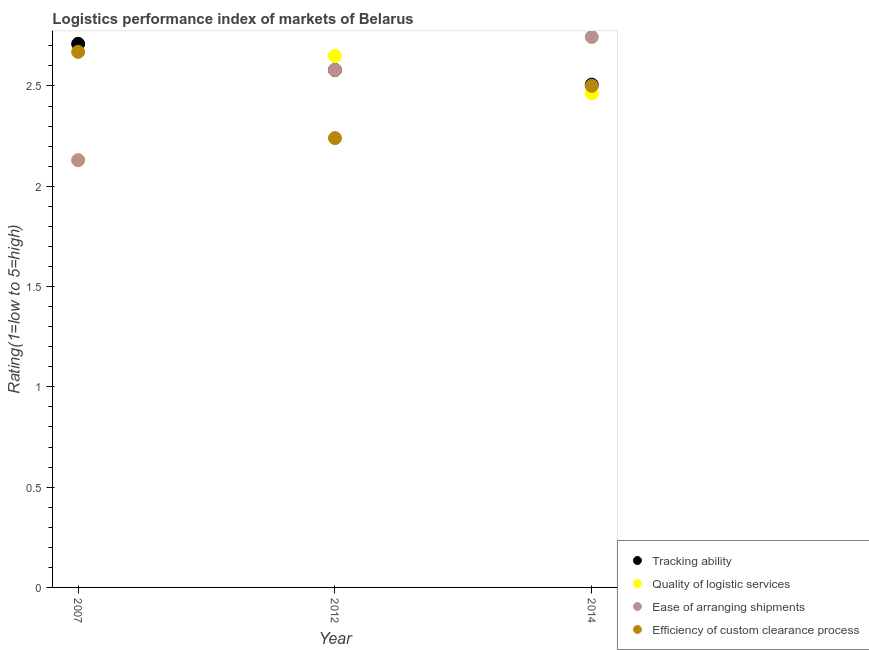Is the number of dotlines equal to the number of legend labels?
Your response must be concise. Yes. What is the lpi rating of tracking ability in 2007?
Keep it short and to the point. 2.71. Across all years, what is the maximum lpi rating of efficiency of custom clearance process?
Ensure brevity in your answer.  2.67. Across all years, what is the minimum lpi rating of tracking ability?
Ensure brevity in your answer.  2.51. What is the total lpi rating of ease of arranging shipments in the graph?
Keep it short and to the point. 7.45. What is the difference between the lpi rating of efficiency of custom clearance process in 2007 and that in 2012?
Keep it short and to the point. 0.43. What is the difference between the lpi rating of quality of logistic services in 2007 and the lpi rating of efficiency of custom clearance process in 2014?
Offer a very short reply. -0.37. What is the average lpi rating of efficiency of custom clearance process per year?
Provide a short and direct response. 2.47. In the year 2012, what is the difference between the lpi rating of tracking ability and lpi rating of quality of logistic services?
Give a very brief answer. -0.07. What is the ratio of the lpi rating of ease of arranging shipments in 2007 to that in 2012?
Your answer should be very brief. 0.83. Is the lpi rating of quality of logistic services in 2007 less than that in 2012?
Offer a very short reply. Yes. Is the difference between the lpi rating of tracking ability in 2012 and 2014 greater than the difference between the lpi rating of quality of logistic services in 2012 and 2014?
Provide a succinct answer. No. What is the difference between the highest and the second highest lpi rating of quality of logistic services?
Keep it short and to the point. 0.19. What is the difference between the highest and the lowest lpi rating of efficiency of custom clearance process?
Keep it short and to the point. 0.43. Does the lpi rating of ease of arranging shipments monotonically increase over the years?
Offer a terse response. Yes. How many dotlines are there?
Keep it short and to the point. 4. How many years are there in the graph?
Provide a succinct answer. 3. Does the graph contain any zero values?
Your response must be concise. No. How many legend labels are there?
Offer a very short reply. 4. What is the title of the graph?
Provide a short and direct response. Logistics performance index of markets of Belarus. Does "Permission" appear as one of the legend labels in the graph?
Ensure brevity in your answer.  No. What is the label or title of the Y-axis?
Provide a succinct answer. Rating(1=low to 5=high). What is the Rating(1=low to 5=high) in Tracking ability in 2007?
Provide a short and direct response. 2.71. What is the Rating(1=low to 5=high) in Quality of logistic services in 2007?
Keep it short and to the point. 2.13. What is the Rating(1=low to 5=high) in Ease of arranging shipments in 2007?
Make the answer very short. 2.13. What is the Rating(1=low to 5=high) in Efficiency of custom clearance process in 2007?
Keep it short and to the point. 2.67. What is the Rating(1=low to 5=high) in Tracking ability in 2012?
Keep it short and to the point. 2.58. What is the Rating(1=low to 5=high) in Quality of logistic services in 2012?
Provide a succinct answer. 2.65. What is the Rating(1=low to 5=high) in Ease of arranging shipments in 2012?
Your response must be concise. 2.58. What is the Rating(1=low to 5=high) in Efficiency of custom clearance process in 2012?
Keep it short and to the point. 2.24. What is the Rating(1=low to 5=high) in Tracking ability in 2014?
Offer a very short reply. 2.51. What is the Rating(1=low to 5=high) of Quality of logistic services in 2014?
Provide a short and direct response. 2.46. What is the Rating(1=low to 5=high) in Ease of arranging shipments in 2014?
Your answer should be compact. 2.74. What is the Rating(1=low to 5=high) of Efficiency of custom clearance process in 2014?
Offer a very short reply. 2.5. Across all years, what is the maximum Rating(1=low to 5=high) in Tracking ability?
Offer a terse response. 2.71. Across all years, what is the maximum Rating(1=low to 5=high) in Quality of logistic services?
Offer a terse response. 2.65. Across all years, what is the maximum Rating(1=low to 5=high) in Ease of arranging shipments?
Ensure brevity in your answer.  2.74. Across all years, what is the maximum Rating(1=low to 5=high) in Efficiency of custom clearance process?
Offer a terse response. 2.67. Across all years, what is the minimum Rating(1=low to 5=high) in Tracking ability?
Your answer should be very brief. 2.51. Across all years, what is the minimum Rating(1=low to 5=high) in Quality of logistic services?
Provide a short and direct response. 2.13. Across all years, what is the minimum Rating(1=low to 5=high) in Ease of arranging shipments?
Keep it short and to the point. 2.13. Across all years, what is the minimum Rating(1=low to 5=high) of Efficiency of custom clearance process?
Your answer should be compact. 2.24. What is the total Rating(1=low to 5=high) of Tracking ability in the graph?
Provide a succinct answer. 7.8. What is the total Rating(1=low to 5=high) in Quality of logistic services in the graph?
Provide a short and direct response. 7.24. What is the total Rating(1=low to 5=high) in Ease of arranging shipments in the graph?
Give a very brief answer. 7.45. What is the total Rating(1=low to 5=high) of Efficiency of custom clearance process in the graph?
Offer a terse response. 7.41. What is the difference between the Rating(1=low to 5=high) of Tracking ability in 2007 and that in 2012?
Your answer should be very brief. 0.13. What is the difference between the Rating(1=low to 5=high) in Quality of logistic services in 2007 and that in 2012?
Ensure brevity in your answer.  -0.52. What is the difference between the Rating(1=low to 5=high) of Ease of arranging shipments in 2007 and that in 2012?
Your answer should be very brief. -0.45. What is the difference between the Rating(1=low to 5=high) in Efficiency of custom clearance process in 2007 and that in 2012?
Ensure brevity in your answer.  0.43. What is the difference between the Rating(1=low to 5=high) in Tracking ability in 2007 and that in 2014?
Your answer should be very brief. 0.2. What is the difference between the Rating(1=low to 5=high) of Quality of logistic services in 2007 and that in 2014?
Your answer should be compact. -0.33. What is the difference between the Rating(1=low to 5=high) of Ease of arranging shipments in 2007 and that in 2014?
Provide a succinct answer. -0.61. What is the difference between the Rating(1=low to 5=high) in Efficiency of custom clearance process in 2007 and that in 2014?
Provide a succinct answer. 0.17. What is the difference between the Rating(1=low to 5=high) of Tracking ability in 2012 and that in 2014?
Your response must be concise. 0.07. What is the difference between the Rating(1=low to 5=high) of Quality of logistic services in 2012 and that in 2014?
Offer a terse response. 0.19. What is the difference between the Rating(1=low to 5=high) of Ease of arranging shipments in 2012 and that in 2014?
Your answer should be compact. -0.16. What is the difference between the Rating(1=low to 5=high) in Efficiency of custom clearance process in 2012 and that in 2014?
Your answer should be compact. -0.26. What is the difference between the Rating(1=low to 5=high) of Tracking ability in 2007 and the Rating(1=low to 5=high) of Ease of arranging shipments in 2012?
Your answer should be compact. 0.13. What is the difference between the Rating(1=low to 5=high) of Tracking ability in 2007 and the Rating(1=low to 5=high) of Efficiency of custom clearance process in 2012?
Your answer should be compact. 0.47. What is the difference between the Rating(1=low to 5=high) of Quality of logistic services in 2007 and the Rating(1=low to 5=high) of Ease of arranging shipments in 2012?
Make the answer very short. -0.45. What is the difference between the Rating(1=low to 5=high) of Quality of logistic services in 2007 and the Rating(1=low to 5=high) of Efficiency of custom clearance process in 2012?
Keep it short and to the point. -0.11. What is the difference between the Rating(1=low to 5=high) in Ease of arranging shipments in 2007 and the Rating(1=low to 5=high) in Efficiency of custom clearance process in 2012?
Your answer should be compact. -0.11. What is the difference between the Rating(1=low to 5=high) in Tracking ability in 2007 and the Rating(1=low to 5=high) in Quality of logistic services in 2014?
Offer a terse response. 0.25. What is the difference between the Rating(1=low to 5=high) of Tracking ability in 2007 and the Rating(1=low to 5=high) of Ease of arranging shipments in 2014?
Make the answer very short. -0.03. What is the difference between the Rating(1=low to 5=high) in Tracking ability in 2007 and the Rating(1=low to 5=high) in Efficiency of custom clearance process in 2014?
Your answer should be compact. 0.21. What is the difference between the Rating(1=low to 5=high) in Quality of logistic services in 2007 and the Rating(1=low to 5=high) in Ease of arranging shipments in 2014?
Provide a short and direct response. -0.61. What is the difference between the Rating(1=low to 5=high) of Quality of logistic services in 2007 and the Rating(1=low to 5=high) of Efficiency of custom clearance process in 2014?
Give a very brief answer. -0.37. What is the difference between the Rating(1=low to 5=high) of Ease of arranging shipments in 2007 and the Rating(1=low to 5=high) of Efficiency of custom clearance process in 2014?
Make the answer very short. -0.37. What is the difference between the Rating(1=low to 5=high) of Tracking ability in 2012 and the Rating(1=low to 5=high) of Quality of logistic services in 2014?
Make the answer very short. 0.12. What is the difference between the Rating(1=low to 5=high) of Tracking ability in 2012 and the Rating(1=low to 5=high) of Ease of arranging shipments in 2014?
Ensure brevity in your answer.  -0.16. What is the difference between the Rating(1=low to 5=high) in Tracking ability in 2012 and the Rating(1=low to 5=high) in Efficiency of custom clearance process in 2014?
Provide a succinct answer. 0.08. What is the difference between the Rating(1=low to 5=high) in Quality of logistic services in 2012 and the Rating(1=low to 5=high) in Ease of arranging shipments in 2014?
Ensure brevity in your answer.  -0.09. What is the difference between the Rating(1=low to 5=high) of Quality of logistic services in 2012 and the Rating(1=low to 5=high) of Efficiency of custom clearance process in 2014?
Provide a short and direct response. 0.15. What is the difference between the Rating(1=low to 5=high) in Ease of arranging shipments in 2012 and the Rating(1=low to 5=high) in Efficiency of custom clearance process in 2014?
Provide a succinct answer. 0.08. What is the average Rating(1=low to 5=high) in Tracking ability per year?
Offer a very short reply. 2.6. What is the average Rating(1=low to 5=high) in Quality of logistic services per year?
Provide a succinct answer. 2.41. What is the average Rating(1=low to 5=high) of Ease of arranging shipments per year?
Ensure brevity in your answer.  2.48. What is the average Rating(1=low to 5=high) of Efficiency of custom clearance process per year?
Your response must be concise. 2.47. In the year 2007, what is the difference between the Rating(1=low to 5=high) in Tracking ability and Rating(1=low to 5=high) in Quality of logistic services?
Keep it short and to the point. 0.58. In the year 2007, what is the difference between the Rating(1=low to 5=high) in Tracking ability and Rating(1=low to 5=high) in Ease of arranging shipments?
Your answer should be compact. 0.58. In the year 2007, what is the difference between the Rating(1=low to 5=high) of Quality of logistic services and Rating(1=low to 5=high) of Ease of arranging shipments?
Keep it short and to the point. 0. In the year 2007, what is the difference between the Rating(1=low to 5=high) in Quality of logistic services and Rating(1=low to 5=high) in Efficiency of custom clearance process?
Your answer should be very brief. -0.54. In the year 2007, what is the difference between the Rating(1=low to 5=high) of Ease of arranging shipments and Rating(1=low to 5=high) of Efficiency of custom clearance process?
Give a very brief answer. -0.54. In the year 2012, what is the difference between the Rating(1=low to 5=high) of Tracking ability and Rating(1=low to 5=high) of Quality of logistic services?
Ensure brevity in your answer.  -0.07. In the year 2012, what is the difference between the Rating(1=low to 5=high) of Tracking ability and Rating(1=low to 5=high) of Ease of arranging shipments?
Your response must be concise. 0. In the year 2012, what is the difference between the Rating(1=low to 5=high) of Tracking ability and Rating(1=low to 5=high) of Efficiency of custom clearance process?
Your answer should be compact. 0.34. In the year 2012, what is the difference between the Rating(1=low to 5=high) in Quality of logistic services and Rating(1=low to 5=high) in Ease of arranging shipments?
Ensure brevity in your answer.  0.07. In the year 2012, what is the difference between the Rating(1=low to 5=high) in Quality of logistic services and Rating(1=low to 5=high) in Efficiency of custom clearance process?
Your response must be concise. 0.41. In the year 2012, what is the difference between the Rating(1=low to 5=high) in Ease of arranging shipments and Rating(1=low to 5=high) in Efficiency of custom clearance process?
Your response must be concise. 0.34. In the year 2014, what is the difference between the Rating(1=low to 5=high) in Tracking ability and Rating(1=low to 5=high) in Quality of logistic services?
Your answer should be compact. 0.04. In the year 2014, what is the difference between the Rating(1=low to 5=high) in Tracking ability and Rating(1=low to 5=high) in Ease of arranging shipments?
Keep it short and to the point. -0.24. In the year 2014, what is the difference between the Rating(1=low to 5=high) in Tracking ability and Rating(1=low to 5=high) in Efficiency of custom clearance process?
Offer a terse response. 0.01. In the year 2014, what is the difference between the Rating(1=low to 5=high) of Quality of logistic services and Rating(1=low to 5=high) of Ease of arranging shipments?
Your response must be concise. -0.28. In the year 2014, what is the difference between the Rating(1=low to 5=high) in Quality of logistic services and Rating(1=low to 5=high) in Efficiency of custom clearance process?
Offer a terse response. -0.04. In the year 2014, what is the difference between the Rating(1=low to 5=high) in Ease of arranging shipments and Rating(1=low to 5=high) in Efficiency of custom clearance process?
Offer a very short reply. 0.24. What is the ratio of the Rating(1=low to 5=high) in Tracking ability in 2007 to that in 2012?
Provide a succinct answer. 1.05. What is the ratio of the Rating(1=low to 5=high) of Quality of logistic services in 2007 to that in 2012?
Your response must be concise. 0.8. What is the ratio of the Rating(1=low to 5=high) in Ease of arranging shipments in 2007 to that in 2012?
Offer a very short reply. 0.83. What is the ratio of the Rating(1=low to 5=high) in Efficiency of custom clearance process in 2007 to that in 2012?
Give a very brief answer. 1.19. What is the ratio of the Rating(1=low to 5=high) in Tracking ability in 2007 to that in 2014?
Your answer should be very brief. 1.08. What is the ratio of the Rating(1=low to 5=high) of Quality of logistic services in 2007 to that in 2014?
Your answer should be compact. 0.86. What is the ratio of the Rating(1=low to 5=high) in Ease of arranging shipments in 2007 to that in 2014?
Your answer should be compact. 0.78. What is the ratio of the Rating(1=low to 5=high) of Efficiency of custom clearance process in 2007 to that in 2014?
Your response must be concise. 1.07. What is the ratio of the Rating(1=low to 5=high) of Tracking ability in 2012 to that in 2014?
Ensure brevity in your answer.  1.03. What is the ratio of the Rating(1=low to 5=high) of Quality of logistic services in 2012 to that in 2014?
Make the answer very short. 1.08. What is the ratio of the Rating(1=low to 5=high) of Ease of arranging shipments in 2012 to that in 2014?
Provide a short and direct response. 0.94. What is the ratio of the Rating(1=low to 5=high) in Efficiency of custom clearance process in 2012 to that in 2014?
Your answer should be very brief. 0.9. What is the difference between the highest and the second highest Rating(1=low to 5=high) in Tracking ability?
Give a very brief answer. 0.13. What is the difference between the highest and the second highest Rating(1=low to 5=high) in Quality of logistic services?
Your answer should be compact. 0.19. What is the difference between the highest and the second highest Rating(1=low to 5=high) of Ease of arranging shipments?
Offer a terse response. 0.16. What is the difference between the highest and the second highest Rating(1=low to 5=high) in Efficiency of custom clearance process?
Offer a very short reply. 0.17. What is the difference between the highest and the lowest Rating(1=low to 5=high) in Tracking ability?
Ensure brevity in your answer.  0.2. What is the difference between the highest and the lowest Rating(1=low to 5=high) of Quality of logistic services?
Your answer should be very brief. 0.52. What is the difference between the highest and the lowest Rating(1=low to 5=high) of Ease of arranging shipments?
Make the answer very short. 0.61. What is the difference between the highest and the lowest Rating(1=low to 5=high) in Efficiency of custom clearance process?
Make the answer very short. 0.43. 